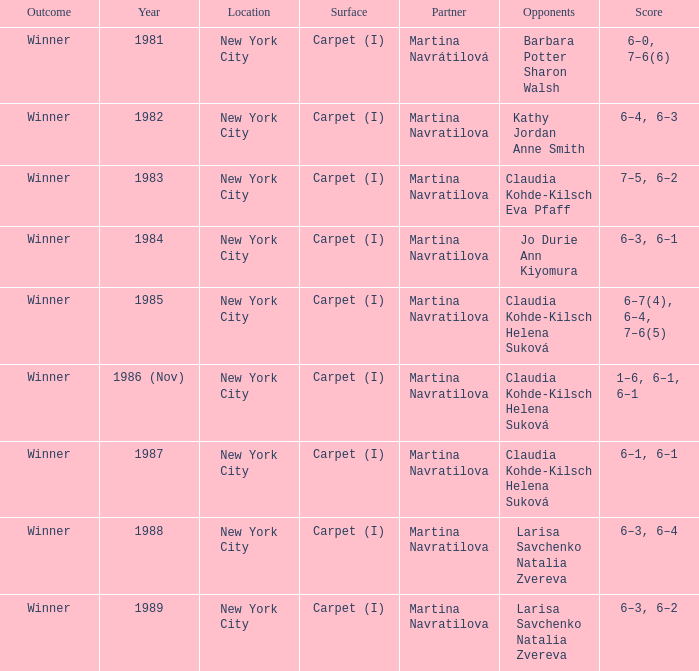Who were all of the adversaries in 1984? Jo Durie Ann Kiyomura. Could you parse the entire table? {'header': ['Outcome', 'Year', 'Location', 'Surface', 'Partner', 'Opponents', 'Score'], 'rows': [['Winner', '1981', 'New York City', 'Carpet (I)', 'Martina Navrátilová', 'Barbara Potter Sharon Walsh', '6–0, 7–6(6)'], ['Winner', '1982', 'New York City', 'Carpet (I)', 'Martina Navratilova', 'Kathy Jordan Anne Smith', '6–4, 6–3'], ['Winner', '1983', 'New York City', 'Carpet (I)', 'Martina Navratilova', 'Claudia Kohde-Kilsch Eva Pfaff', '7–5, 6–2'], ['Winner', '1984', 'New York City', 'Carpet (I)', 'Martina Navratilova', 'Jo Durie Ann Kiyomura', '6–3, 6–1'], ['Winner', '1985', 'New York City', 'Carpet (I)', 'Martina Navratilova', 'Claudia Kohde-Kilsch Helena Suková', '6–7(4), 6–4, 7–6(5)'], ['Winner', '1986 (Nov)', 'New York City', 'Carpet (I)', 'Martina Navratilova', 'Claudia Kohde-Kilsch Helena Suková', '1–6, 6–1, 6–1'], ['Winner', '1987', 'New York City', 'Carpet (I)', 'Martina Navratilova', 'Claudia Kohde-Kilsch Helena Suková', '6–1, 6–1'], ['Winner', '1988', 'New York City', 'Carpet (I)', 'Martina Navratilova', 'Larisa Savchenko Natalia Zvereva', '6–3, 6–4'], ['Winner', '1989', 'New York City', 'Carpet (I)', 'Martina Navratilova', 'Larisa Savchenko Natalia Zvereva', '6–3, 6–2']]} 